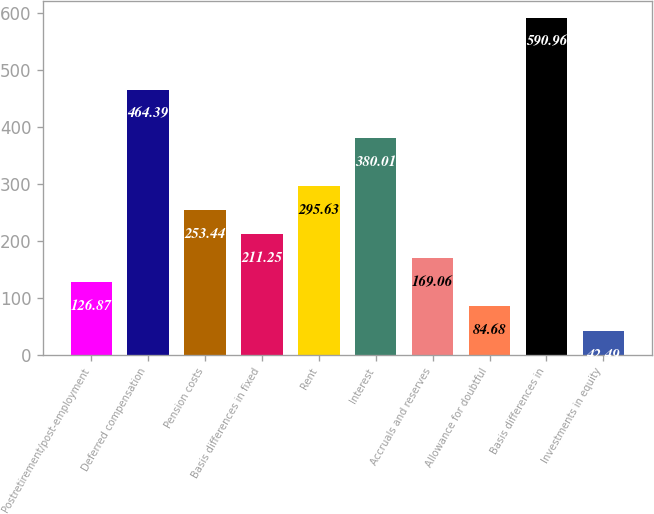Convert chart to OTSL. <chart><loc_0><loc_0><loc_500><loc_500><bar_chart><fcel>Postretirement/post-employment<fcel>Deferred compensation<fcel>Pension costs<fcel>Basis differences in fixed<fcel>Rent<fcel>Interest<fcel>Accruals and reserves<fcel>Allowance for doubtful<fcel>Basis differences in<fcel>Investments in equity<nl><fcel>126.87<fcel>464.39<fcel>253.44<fcel>211.25<fcel>295.63<fcel>380.01<fcel>169.06<fcel>84.68<fcel>590.96<fcel>42.49<nl></chart> 